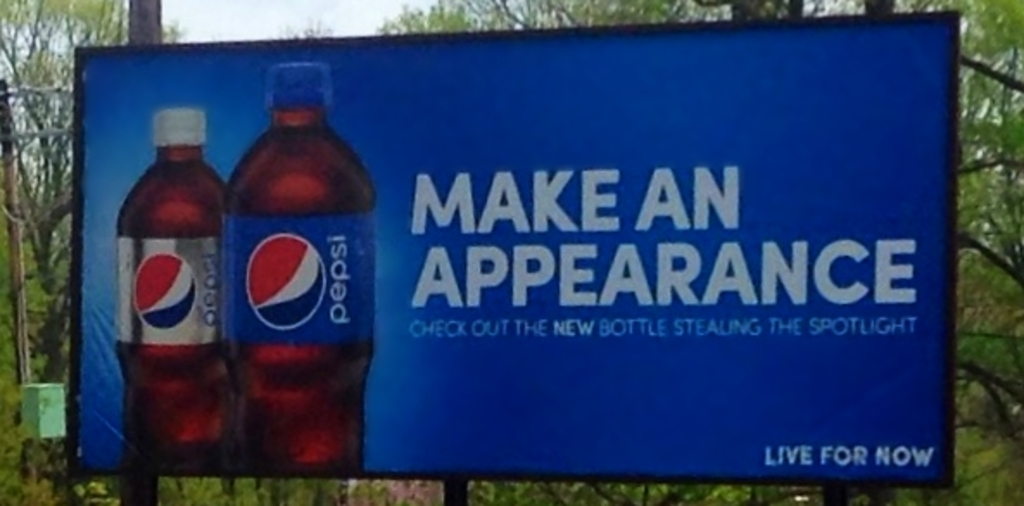What effect does the blue color of the background have on the advertisement? The blue background in the billboard serves multiple purposes; aesthetically, it creates a vibrant contrast that makes the red of the Pepsi bottles pop, drawing viewers' eyes directly to the product. Symbolically, blue is often associated with freshness, trust, and reliability, which can enhance the viewer's perception of Pepsi as a trustworthy and refreshing brand. 